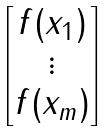Convert formula to latex. <formula><loc_0><loc_0><loc_500><loc_500>\begin{bmatrix} f ( x _ { 1 } ) \\ \vdots \\ f ( x _ { m } ) \end{bmatrix}</formula> 